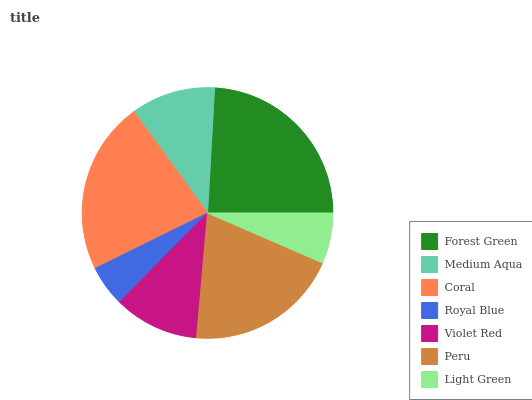Is Royal Blue the minimum?
Answer yes or no. Yes. Is Forest Green the maximum?
Answer yes or no. Yes. Is Medium Aqua the minimum?
Answer yes or no. No. Is Medium Aqua the maximum?
Answer yes or no. No. Is Forest Green greater than Medium Aqua?
Answer yes or no. Yes. Is Medium Aqua less than Forest Green?
Answer yes or no. Yes. Is Medium Aqua greater than Forest Green?
Answer yes or no. No. Is Forest Green less than Medium Aqua?
Answer yes or no. No. Is Violet Red the high median?
Answer yes or no. Yes. Is Violet Red the low median?
Answer yes or no. Yes. Is Forest Green the high median?
Answer yes or no. No. Is Coral the low median?
Answer yes or no. No. 